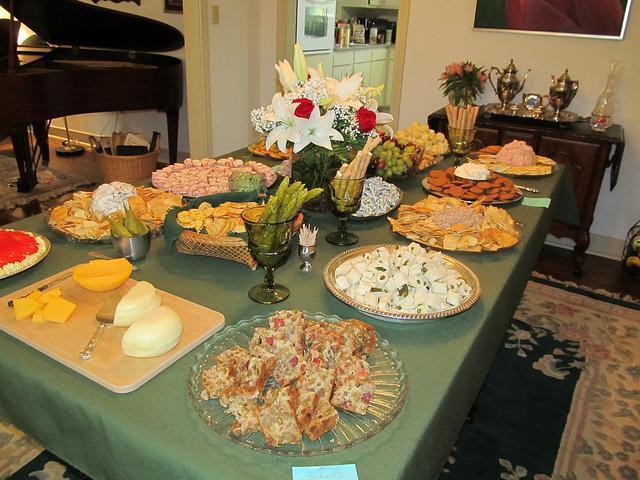How many potted plants are in the picture?
Give a very brief answer. 1. How many sheep are laying down?
Give a very brief answer. 0. 